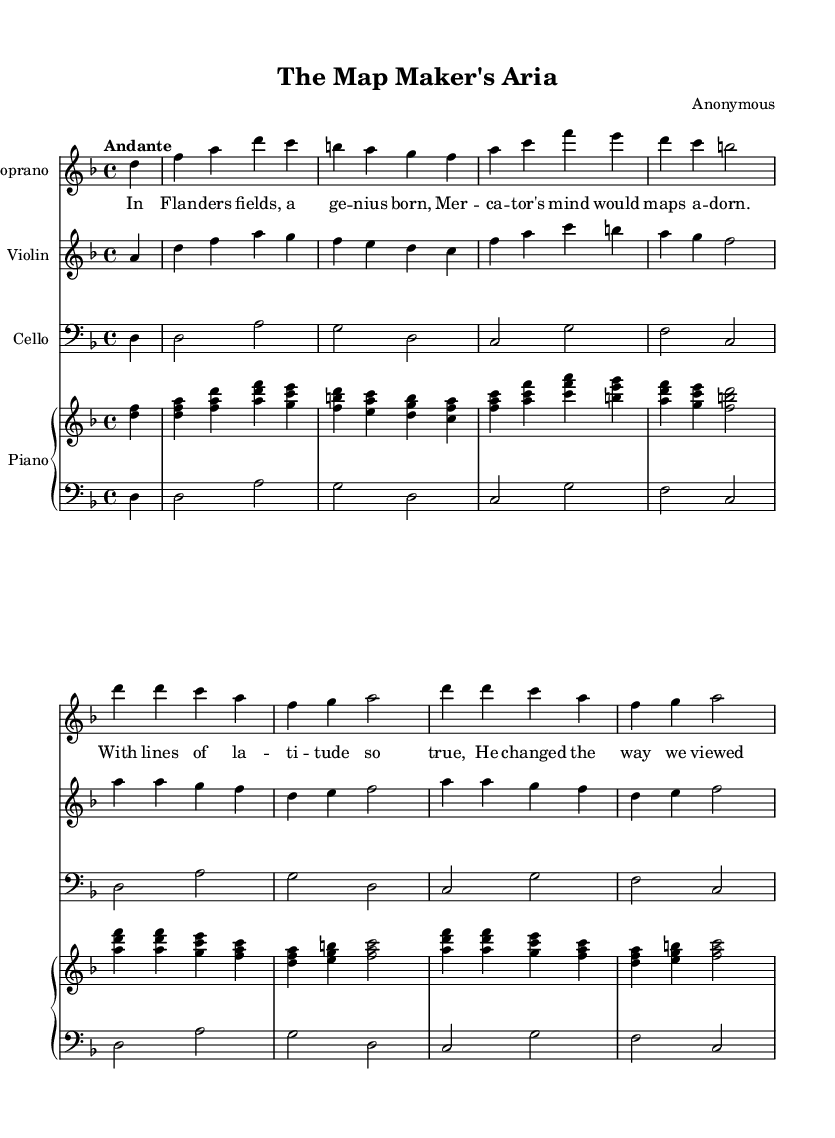What is the key signature of this music? The key signature is indicated at the beginning of the score; here, it shows one flat, which denotes D minor.
Answer: D minor What is the time signature of the piece? The time signature is indicated at the beginning of the score, formatted as a fraction. In this case, it shows four beats in a measure, which is represented as 4/4.
Answer: 4/4 What tempo marking is given? The tempo marking appears above the staff and indicates the desired speed of the music. Here, it is marked "Andante," which suggests a moderately slow pace.
Answer: Andante How many verses are there in the piece? The lyrics section of the score shows that the music has one verse, followed by a chorus. Counting these, we find that there is one verse.
Answer: One What is the title of the piece? The title is found at the top of the score, indicating the name given to the composition. It reads "The Map Maker's Aria."
Answer: The Map Maker's Aria Who is the composer of the opera piece? The composer's name is noted in the header section of the score, and it states "Anonymous," indicating that the actual composer is unknown.
Answer: Anonymous What is the instrument that reads the bass clef? In the score, there is an indication for the instrument that uses the bass clef, which is specific to the cello part shown in the staff layout.
Answer: Cello 